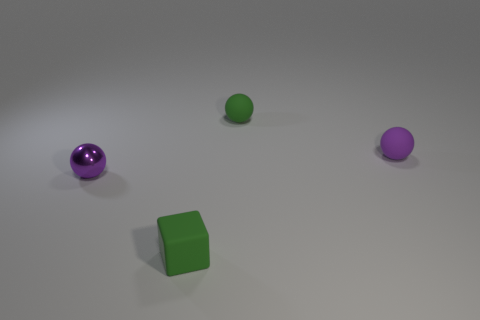Is the shape of the object that is in front of the shiny ball the same as  the purple metal object?
Offer a very short reply. No. How many objects are tiny green things or tiny green objects on the right side of the green matte block?
Make the answer very short. 2. Is the number of tiny green balls less than the number of purple objects?
Ensure brevity in your answer.  Yes. Are there more tiny yellow rubber cylinders than shiny balls?
Offer a terse response. No. How many other objects are there of the same material as the green ball?
Make the answer very short. 2. There is a purple thing in front of the tiny purple sphere on the right side of the tiny green sphere; what number of tiny metallic balls are behind it?
Keep it short and to the point. 0. How many metal things are either purple objects or small green spheres?
Make the answer very short. 1. What size is the green matte object that is in front of the sphere that is in front of the small purple rubber ball?
Your answer should be compact. Small. Do the object to the left of the tiny cube and the tiny rubber thing that is to the left of the tiny green ball have the same color?
Your response must be concise. No. What color is the tiny sphere that is both on the right side of the matte block and left of the tiny purple rubber thing?
Your response must be concise. Green. 